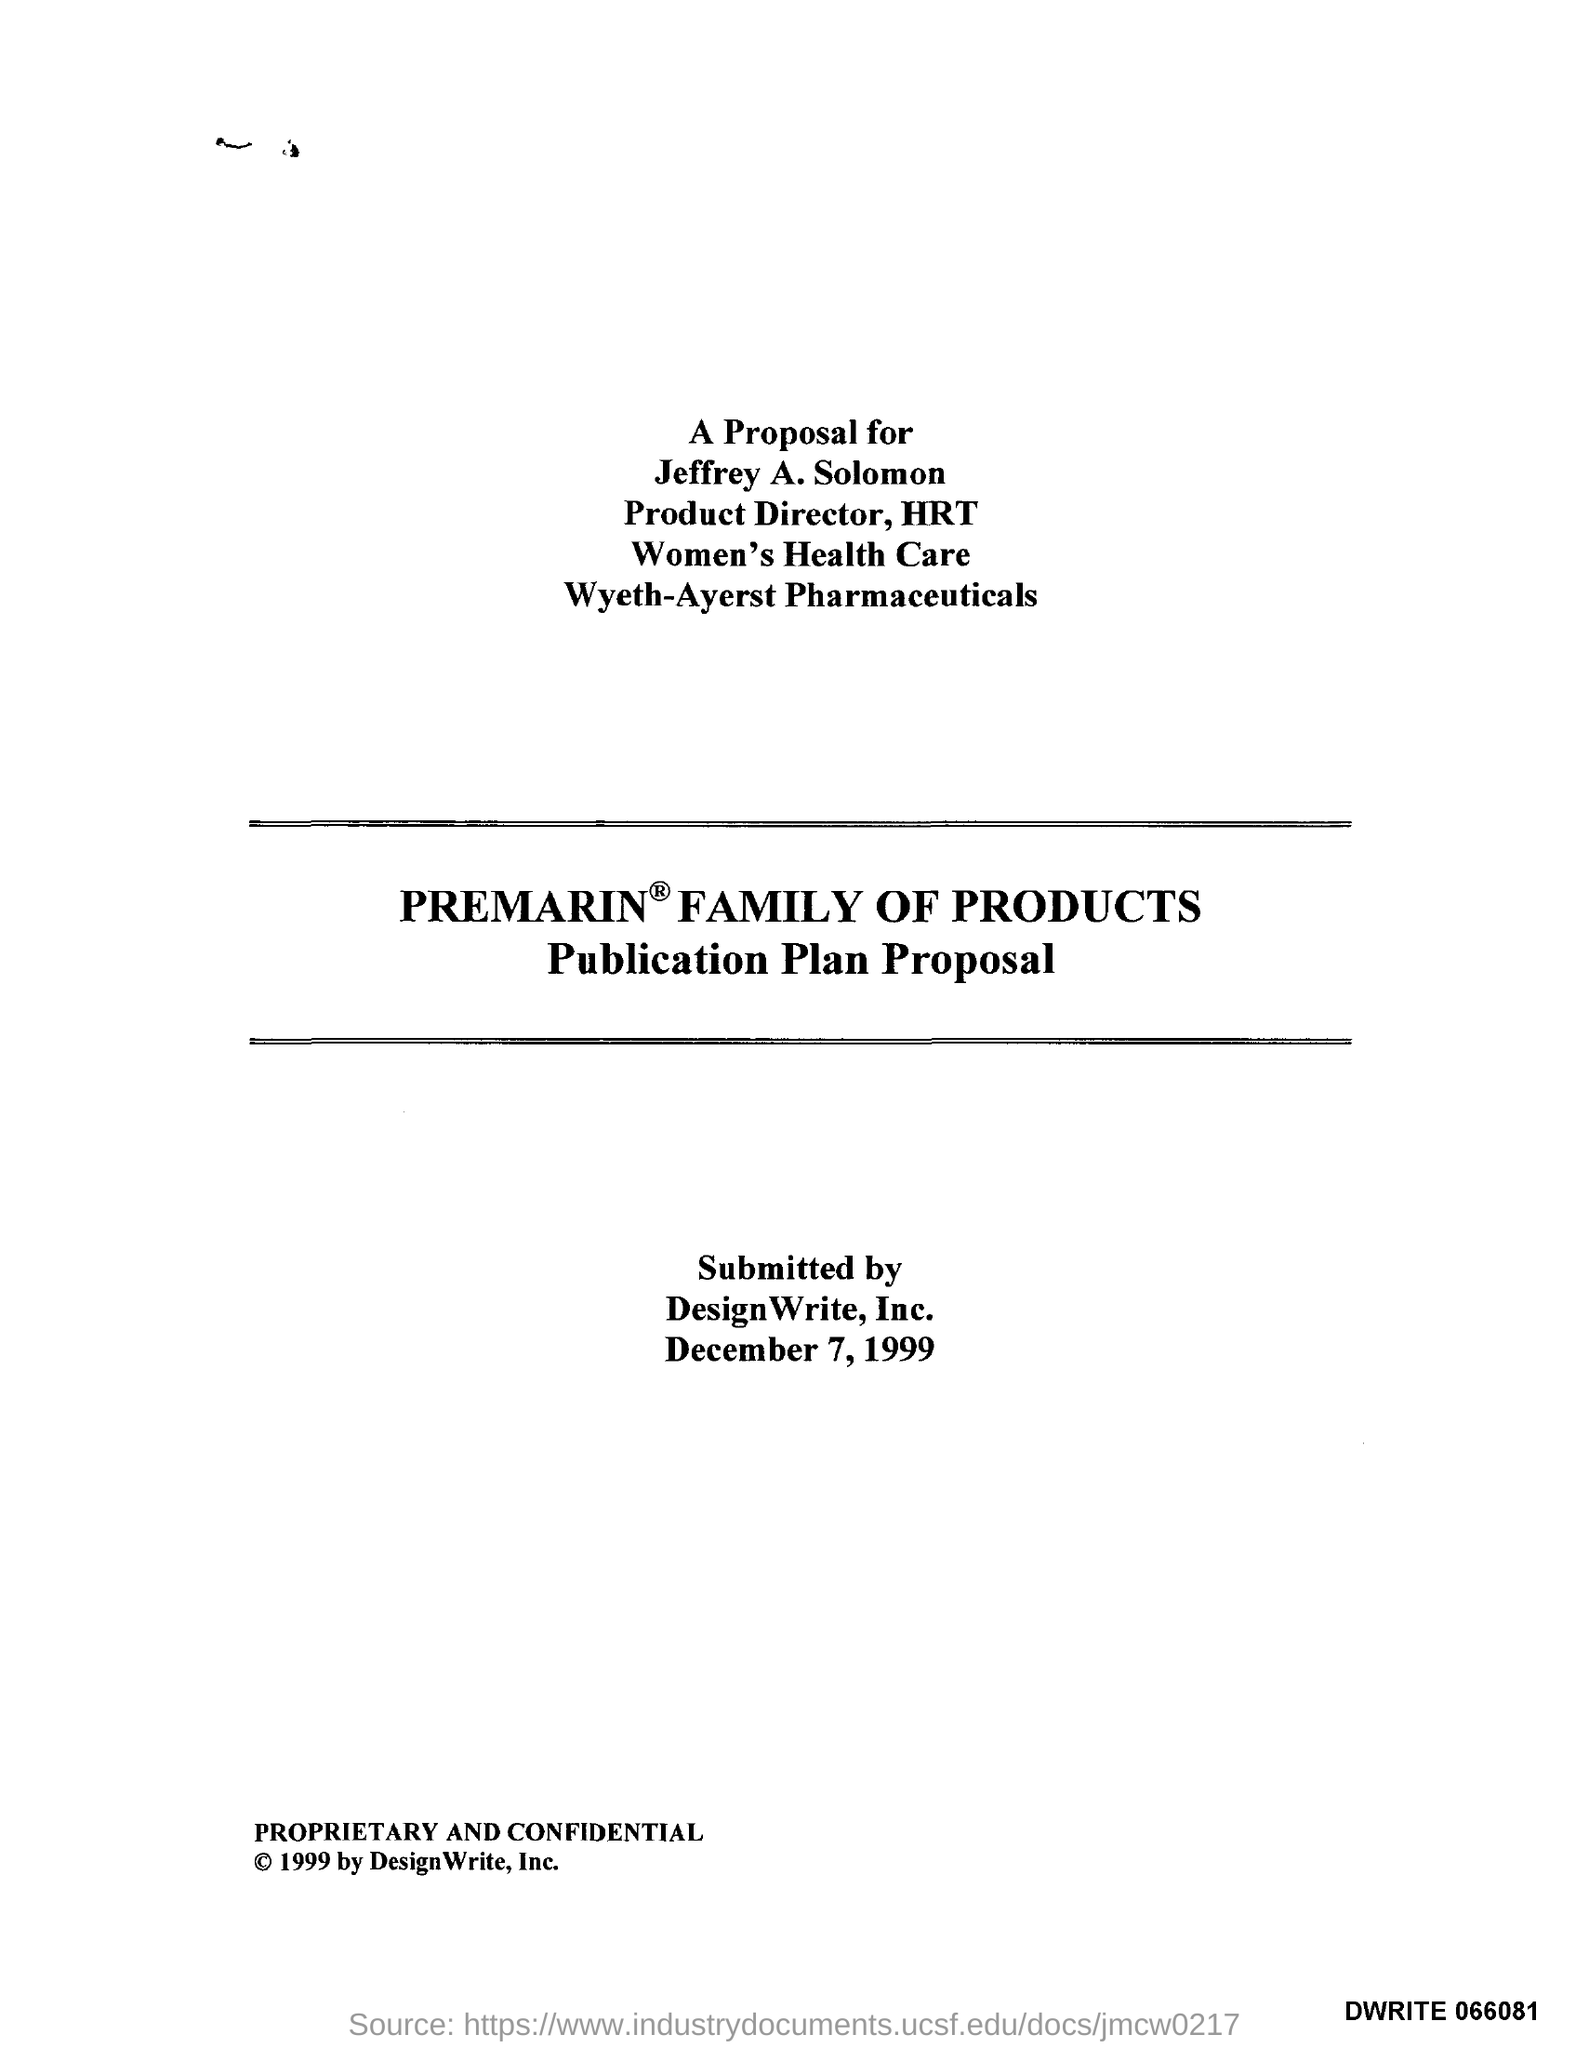Give some essential details in this illustration. The submitted date is December 7, 1999. The proposal is intended for Jeffrey A. Solomon. 